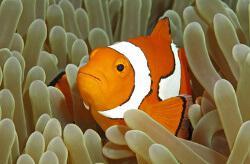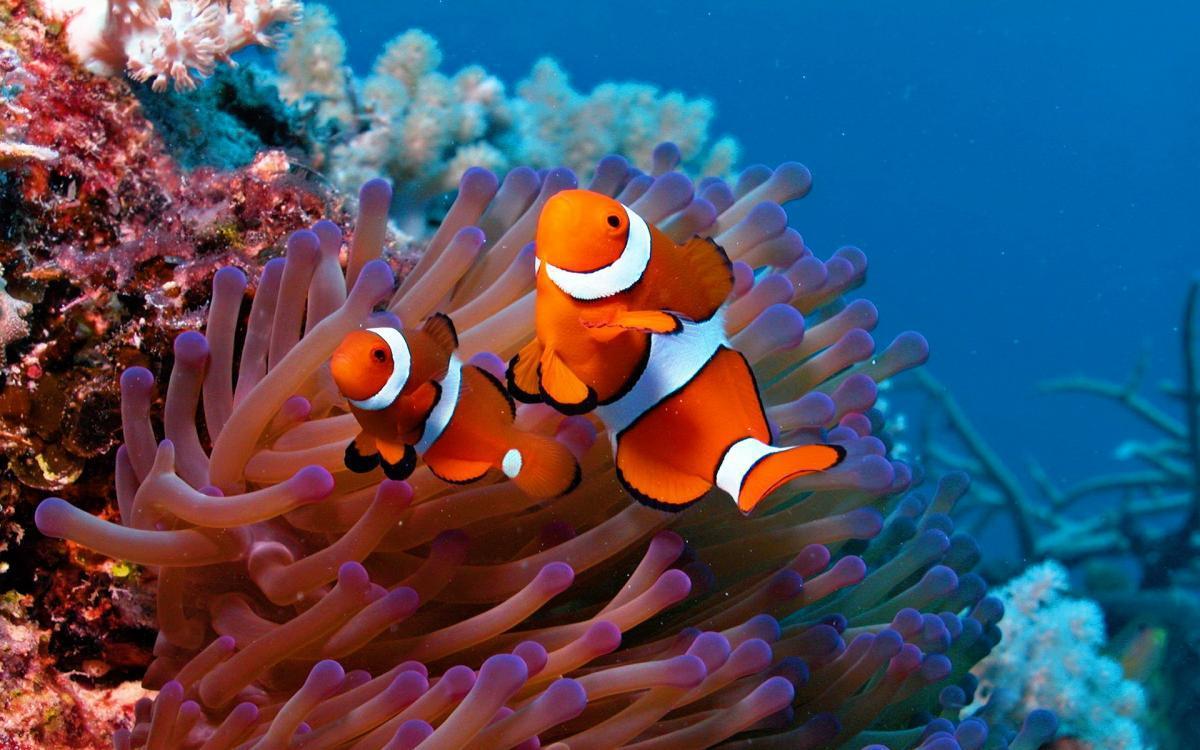The first image is the image on the left, the second image is the image on the right. Evaluate the accuracy of this statement regarding the images: "There are 5 clownfish swimming.". Is it true? Answer yes or no. No. 